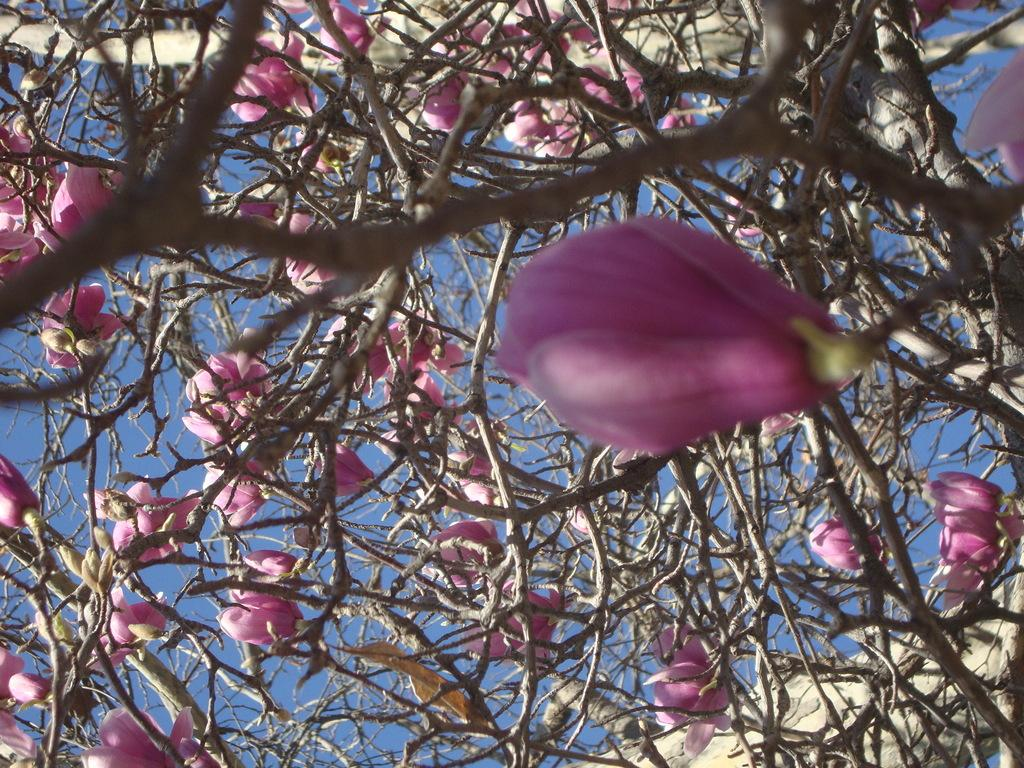What type of flowers are on the tree in the image? There are beautiful flowers on the tree in the image. What color are the flowers? The flowers are pink in color. What can be seen at the top of the image? The sky is visible at the top of the image. Can you tell me how many birds are sitting on the flowers in the image? There are no birds present in the image; it only features flowers on a tree. What type of debt is being discussed in the image? There is no mention of debt in the image; it focuses on flowers on a tree and the sky. 